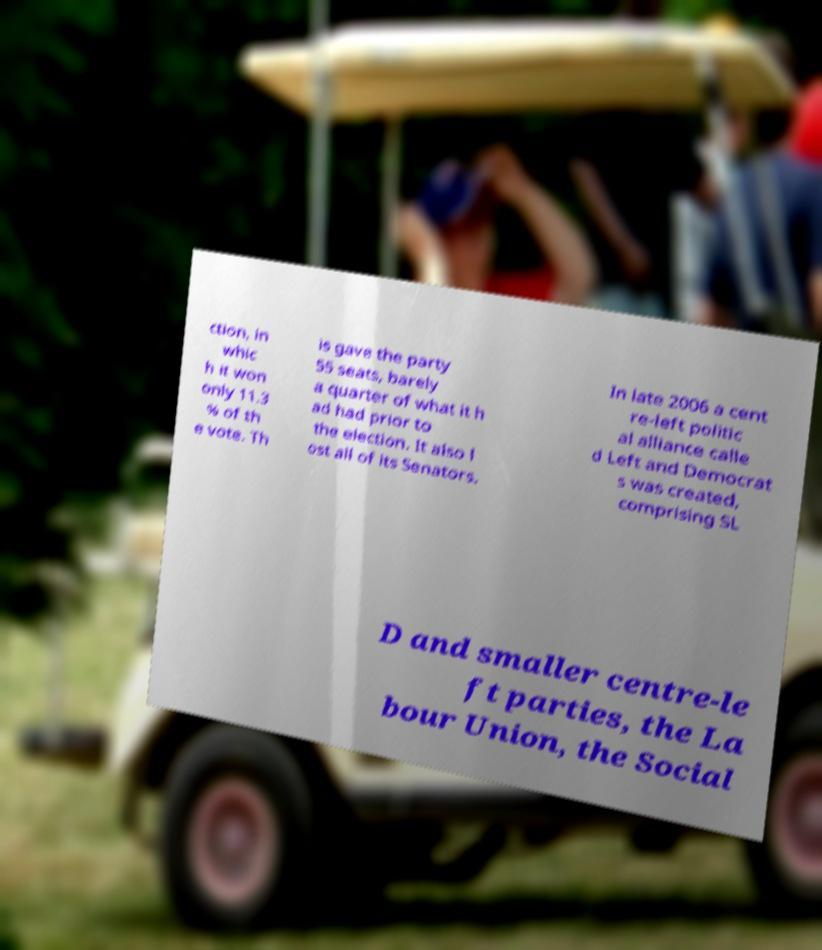Could you extract and type out the text from this image? ction, in whic h it won only 11.3 % of th e vote. Th is gave the party 55 seats, barely a quarter of what it h ad had prior to the election. It also l ost all of its Senators. In late 2006 a cent re-left politic al alliance calle d Left and Democrat s was created, comprising SL D and smaller centre-le ft parties, the La bour Union, the Social 